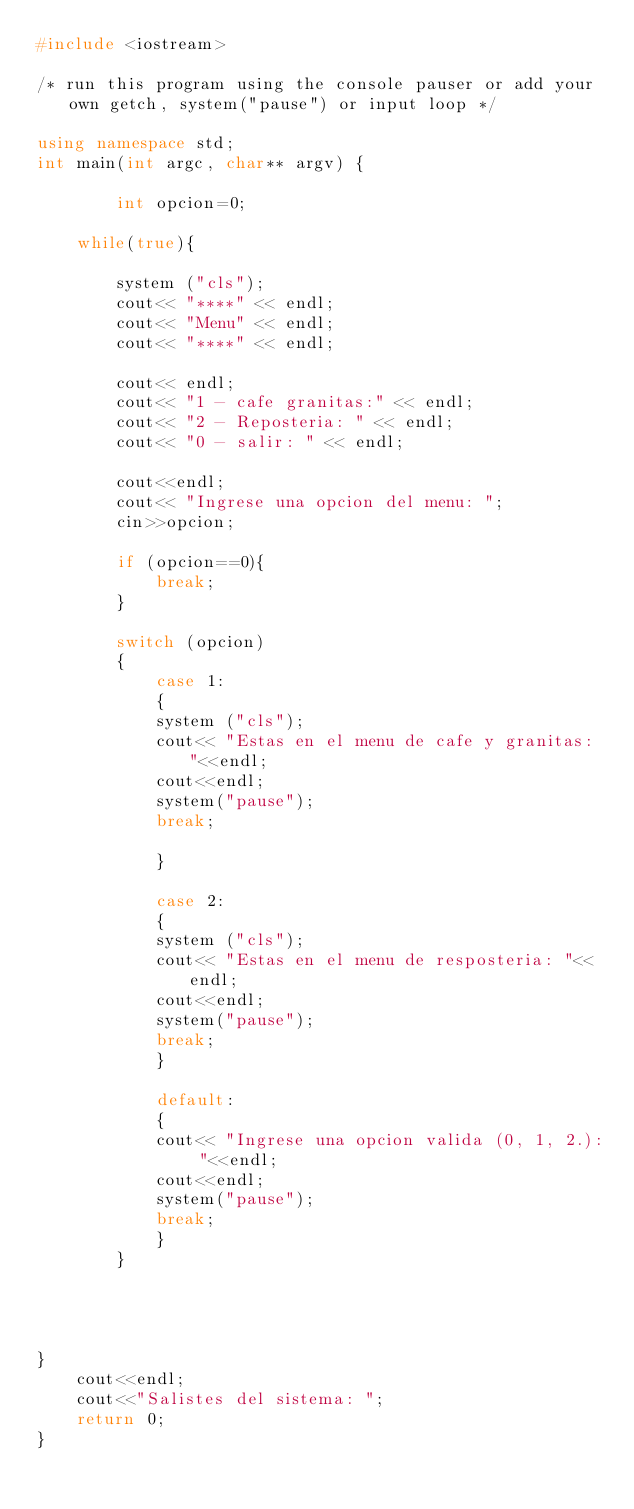Convert code to text. <code><loc_0><loc_0><loc_500><loc_500><_C++_>#include <iostream>

/* run this program using the console pauser or add your own getch, system("pause") or input loop */

using namespace std;
int main(int argc, char** argv) {
	
		int opcion=0;
	
	while(true){
		
		system ("cls");
		cout<< "****" << endl;
		cout<< "Menu" << endl;
		cout<< "****" << endl;
		
		cout<< endl;
		cout<< "1 - cafe granitas:" << endl;
		cout<< "2 - Reposteria: " << endl;
		cout<< "0 - salir: " << endl;
		
		cout<<endl;
		cout<< "Ingrese una opcion del menu: ";
		cin>>opcion;
		
		if (opcion==0){
			break;
		}
		
		switch (opcion)
		{
			case 1:
			{
			system ("cls");
			cout<< "Estas en el menu de cafe y granitas: "<<endl;
			cout<<endl;
			system("pause");
			break;
					
			}
			
			case 2:
			{
			system ("cls");
			cout<< "Estas en el menu de resposteria: "<<endl;
			cout<<endl;
			system("pause");
			break;
			}
			
			default:
			{
			cout<< "Ingrese una opcion valida (0, 1, 2.): "<<endl;
			cout<<endl;
			system("pause");
			break;
			}
		}
		
		
		
		
}
	cout<<endl;
	cout<<"Salistes del sistema: ";
	return 0;
}
</code> 